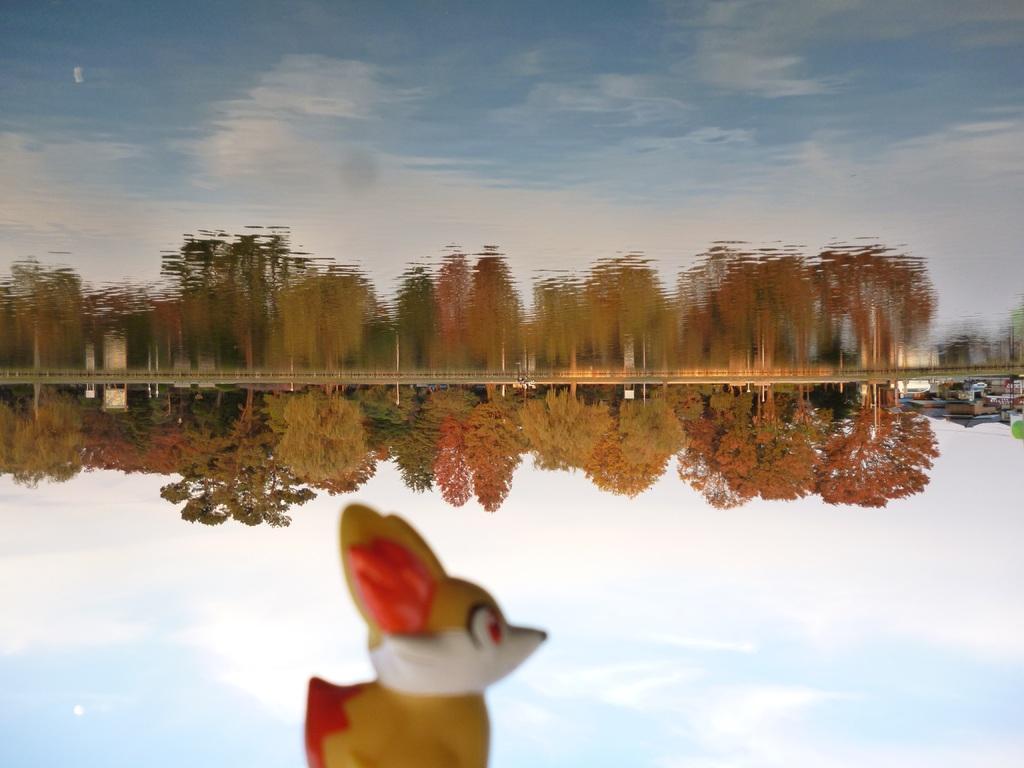How would you summarize this image in a sentence or two? In this image there are few trees, a toy and some clouds in the water, there are reflections of trees, clouds and sky in the water. 